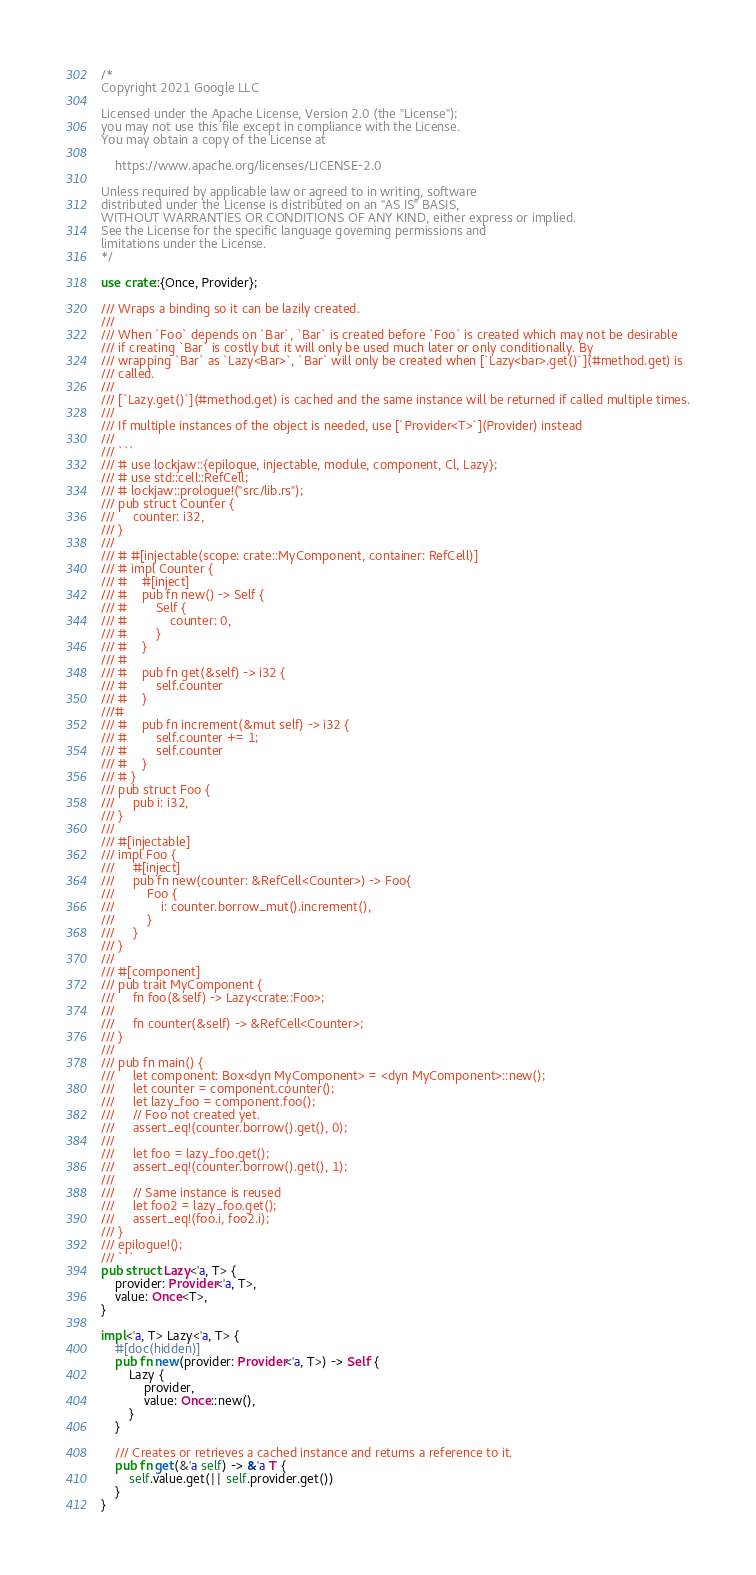<code> <loc_0><loc_0><loc_500><loc_500><_Rust_>/*
Copyright 2021 Google LLC

Licensed under the Apache License, Version 2.0 (the "License");
you may not use this file except in compliance with the License.
You may obtain a copy of the License at

    https://www.apache.org/licenses/LICENSE-2.0

Unless required by applicable law or agreed to in writing, software
distributed under the License is distributed on an "AS IS" BASIS,
WITHOUT WARRANTIES OR CONDITIONS OF ANY KIND, either express or implied.
See the License for the specific language governing permissions and
limitations under the License.
*/

use crate::{Once, Provider};

/// Wraps a binding so it can be lazily created.
///
/// When `Foo` depends on `Bar`, `Bar` is created before `Foo` is created which may not be desirable
/// if creating `Bar` is costly but it will only be used much later or only conditionally. By
/// wrapping `Bar` as `Lazy<Bar>`, `Bar` will only be created when [`Lazy<bar>.get()`](#method.get) is
/// called.
///
/// [`Lazy.get()`](#method.get) is cached and the same instance will be returned if called multiple times.
///
/// If multiple instances of the object is needed, use [`Provider<T>`](Provider) instead
///
/// ```
/// # use lockjaw::{epilogue, injectable, module, component, Cl, Lazy};
/// # use std::cell::RefCell;
/// # lockjaw::prologue!("src/lib.rs");
/// pub struct Counter {
///     counter: i32,
/// }
///
/// # #[injectable(scope: crate::MyComponent, container: RefCell)]
/// # impl Counter {
/// #    #[inject]
/// #    pub fn new() -> Self {
/// #        Self {
/// #            counter: 0,
/// #        }
/// #    }
/// #
/// #    pub fn get(&self) -> i32 {
/// #        self.counter
/// #    }
///#
/// #    pub fn increment(&mut self) -> i32 {
/// #        self.counter += 1;
/// #        self.counter
/// #    }
/// # }
/// pub struct Foo {
///     pub i: i32,
/// }
///
/// #[injectable]
/// impl Foo {
///     #[inject]
///     pub fn new(counter: &RefCell<Counter>) -> Foo{
///         Foo {
///             i: counter.borrow_mut().increment(),
///         }
///     }
/// }
///
/// #[component]
/// pub trait MyComponent {
///     fn foo(&self) -> Lazy<crate::Foo>;
///
///     fn counter(&self) -> &RefCell<Counter>;
/// }
///
/// pub fn main() {
///     let component: Box<dyn MyComponent> = <dyn MyComponent>::new();
///     let counter = component.counter();
///     let lazy_foo = component.foo();
///     // Foo not created yet.
///     assert_eq!(counter.borrow().get(), 0);
///     
///     let foo = lazy_foo.get();
///     assert_eq!(counter.borrow().get(), 1);
///
///     // Same instance is reused
///     let foo2 = lazy_foo.get();
///     assert_eq!(foo.i, foo2.i);
/// }
/// epilogue!();
/// ```
pub struct Lazy<'a, T> {
    provider: Provider<'a, T>,
    value: Once<T>,
}

impl<'a, T> Lazy<'a, T> {
    #[doc(hidden)]
    pub fn new(provider: Provider<'a, T>) -> Self {
        Lazy {
            provider,
            value: Once::new(),
        }
    }

    /// Creates or retrieves a cached instance and returns a reference to it.
    pub fn get(&'a self) -> &'a T {
        self.value.get(|| self.provider.get())
    }
}
</code> 